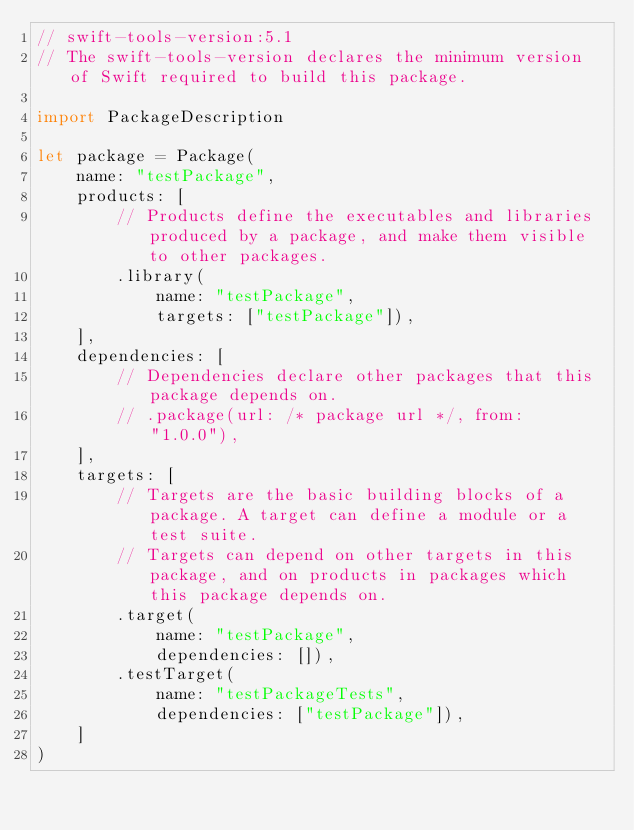<code> <loc_0><loc_0><loc_500><loc_500><_Swift_>// swift-tools-version:5.1
// The swift-tools-version declares the minimum version of Swift required to build this package.

import PackageDescription

let package = Package(
    name: "testPackage",
    products: [
        // Products define the executables and libraries produced by a package, and make them visible to other packages.
        .library(
            name: "testPackage",
            targets: ["testPackage"]),
    ],
    dependencies: [
        // Dependencies declare other packages that this package depends on.
        // .package(url: /* package url */, from: "1.0.0"),
    ],
    targets: [
        // Targets are the basic building blocks of a package. A target can define a module or a test suite.
        // Targets can depend on other targets in this package, and on products in packages which this package depends on.
        .target(
            name: "testPackage",
            dependencies: []),
        .testTarget(
            name: "testPackageTests",
            dependencies: ["testPackage"]),
    ]
)
</code> 